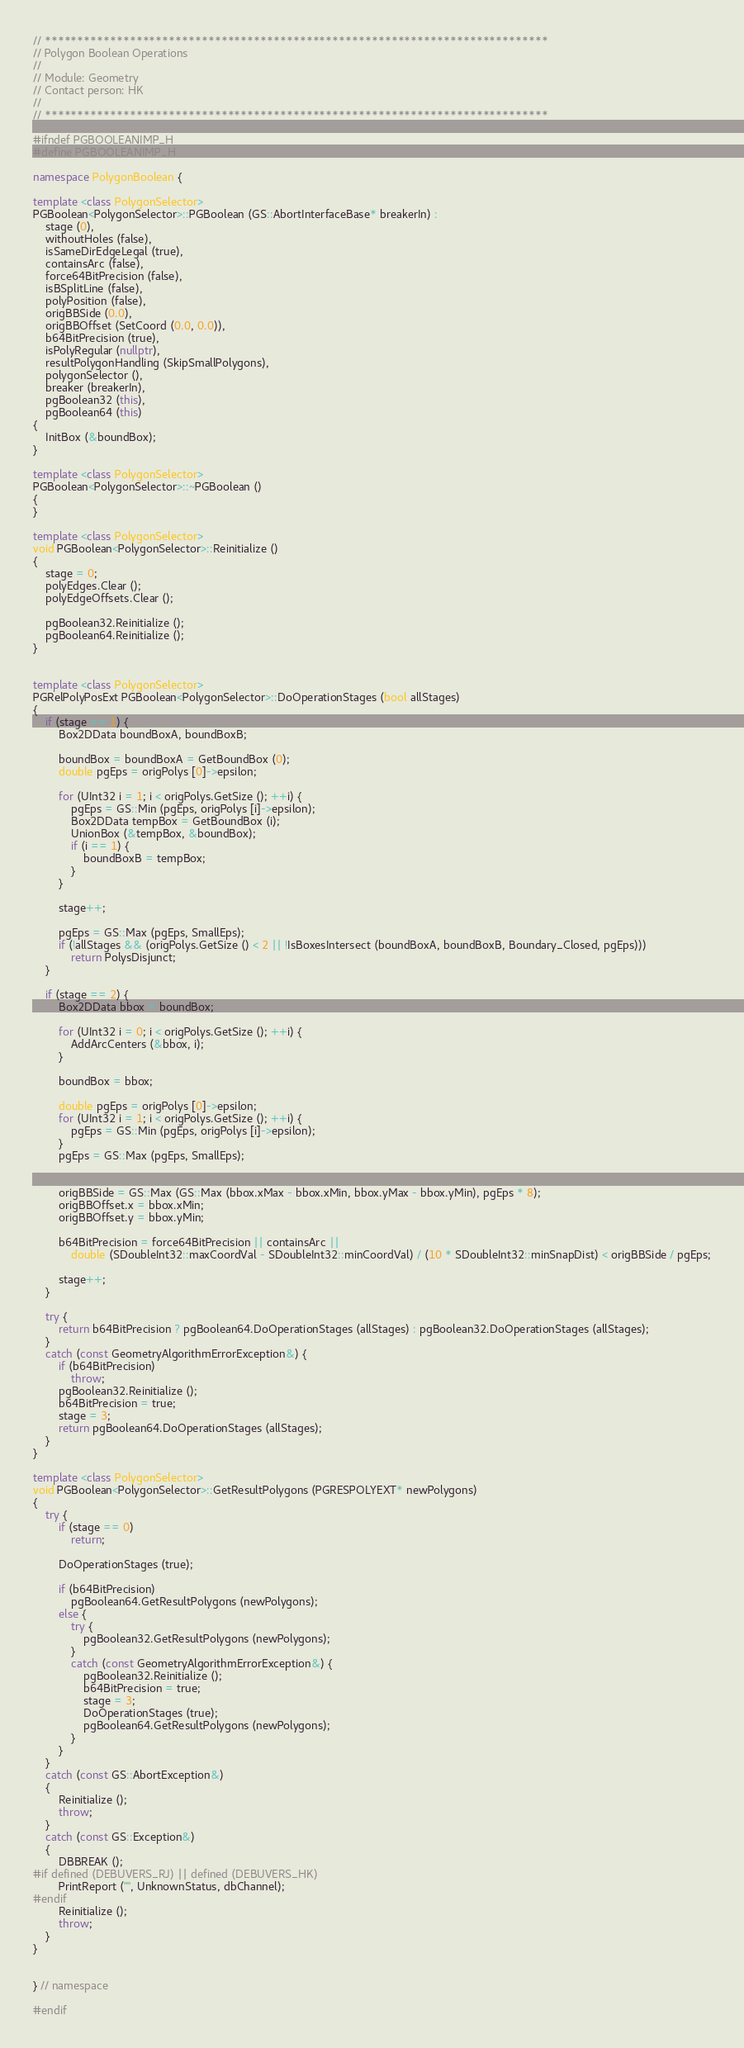Convert code to text. <code><loc_0><loc_0><loc_500><loc_500><_C++_>// *****************************************************************************
// Polygon Boolean Operations
//
// Module: Geometry
// Contact person: HK
//
// *****************************************************************************

#ifndef PGBOOLEANIMP_H
#define PGBOOLEANIMP_H

namespace PolygonBoolean {

template <class PolygonSelector>
PGBoolean<PolygonSelector>::PGBoolean (GS::AbortInterfaceBase* breakerIn) :
	stage (0),
	withoutHoles (false),
	isSameDirEdgeLegal (true),
	containsArc (false),
	force64BitPrecision (false),
	isBSplitLine (false),
	polyPosition (false),
	origBBSide (0.0),
	origBBOffset (SetCoord (0.0, 0.0)),
	b64BitPrecision (true),
	isPolyRegular (nullptr),
	resultPolygonHandling (SkipSmallPolygons),
	polygonSelector (),
	breaker (breakerIn),
	pgBoolean32 (this),
	pgBoolean64 (this)
{
	InitBox (&boundBox);
}

template <class PolygonSelector>
PGBoolean<PolygonSelector>::~PGBoolean ()
{
}

template <class PolygonSelector>
void PGBoolean<PolygonSelector>::Reinitialize ()
{
	stage = 0;
	polyEdges.Clear ();
	polyEdgeOffsets.Clear ();

	pgBoolean32.Reinitialize ();
	pgBoolean64.Reinitialize ();
}


template <class PolygonSelector>
PGRelPolyPosExt PGBoolean<PolygonSelector>::DoOperationStages (bool allStages)
{
	if (stage == 1) {
		Box2DData boundBoxA, boundBoxB;

		boundBox = boundBoxA = GetBoundBox (0);
		double pgEps = origPolys [0]->epsilon;

		for (UInt32 i = 1; i < origPolys.GetSize (); ++i) {
			pgEps = GS::Min (pgEps, origPolys [i]->epsilon);
			Box2DData tempBox = GetBoundBox (i);
			UnionBox (&tempBox, &boundBox);
			if (i == 1) {
				boundBoxB = tempBox;
			}
		}

		stage++;

		pgEps = GS::Max (pgEps, SmallEps);
		if (!allStages && (origPolys.GetSize () < 2 || !IsBoxesIntersect (boundBoxA, boundBoxB, Boundary_Closed, pgEps)))
			return PolysDisjunct;
	}

	if (stage == 2) {
		Box2DData bbox = boundBox;

		for (UInt32 i = 0; i < origPolys.GetSize (); ++i) {
			AddArcCenters (&bbox, i);
		}

		boundBox = bbox;

		double pgEps = origPolys [0]->epsilon;
		for (UInt32 i = 1; i < origPolys.GetSize (); ++i) {
			pgEps = GS::Min (pgEps, origPolys [i]->epsilon);
		}
		pgEps = GS::Max (pgEps, SmallEps);


		origBBSide = GS::Max (GS::Max (bbox.xMax - bbox.xMin, bbox.yMax - bbox.yMin), pgEps * 8);
		origBBOffset.x = bbox.xMin;
		origBBOffset.y = bbox.yMin;

		b64BitPrecision = force64BitPrecision || containsArc ||
			double (SDoubleInt32::maxCoordVal - SDoubleInt32::minCoordVal) / (10 * SDoubleInt32::minSnapDist) < origBBSide / pgEps;

		stage++;
	}

	try {
		return b64BitPrecision ? pgBoolean64.DoOperationStages (allStages) : pgBoolean32.DoOperationStages (allStages);
	}
	catch (const GeometryAlgorithmErrorException&) {
		if (b64BitPrecision)
			throw;
		pgBoolean32.Reinitialize ();
		b64BitPrecision = true;
		stage = 3;
		return pgBoolean64.DoOperationStages (allStages);
	}
}

template <class PolygonSelector>
void PGBoolean<PolygonSelector>::GetResultPolygons (PGRESPOLYEXT* newPolygons)
{
	try {
		if (stage == 0)
			return;

		DoOperationStages (true);

		if (b64BitPrecision)
			pgBoolean64.GetResultPolygons (newPolygons);
		else {
			try {
				pgBoolean32.GetResultPolygons (newPolygons);
			}
			catch (const GeometryAlgorithmErrorException&) {
				pgBoolean32.Reinitialize ();
				b64BitPrecision = true;
				stage = 3;
				DoOperationStages (true);
				pgBoolean64.GetResultPolygons (newPolygons);
			}
		}
	}
	catch (const GS::AbortException&)
	{
		Reinitialize ();
		throw;
	}	
	catch (const GS::Exception&)
	{
		DBBREAK ();
#if defined (DEBUVERS_RJ) || defined (DEBUVERS_HK)
		PrintReport ("", UnknownStatus, dbChannel);
#endif
		Reinitialize ();
		throw;
	}
}


} // namespace

#endif</code> 